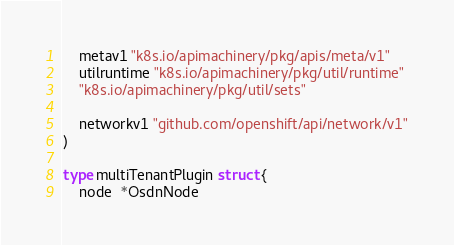<code> <loc_0><loc_0><loc_500><loc_500><_Go_>	metav1 "k8s.io/apimachinery/pkg/apis/meta/v1"
	utilruntime "k8s.io/apimachinery/pkg/util/runtime"
	"k8s.io/apimachinery/pkg/util/sets"

	networkv1 "github.com/openshift/api/network/v1"
)

type multiTenantPlugin struct {
	node  *OsdnNode</code> 